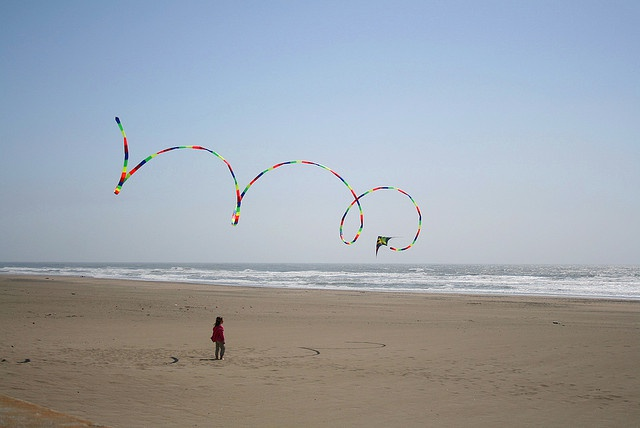Describe the objects in this image and their specific colors. I can see people in gray, black, and maroon tones and kite in gray, lightgray, black, and darkgray tones in this image. 